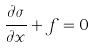<formula> <loc_0><loc_0><loc_500><loc_500>\frac { \partial \sigma } { \partial x } + f = 0</formula> 